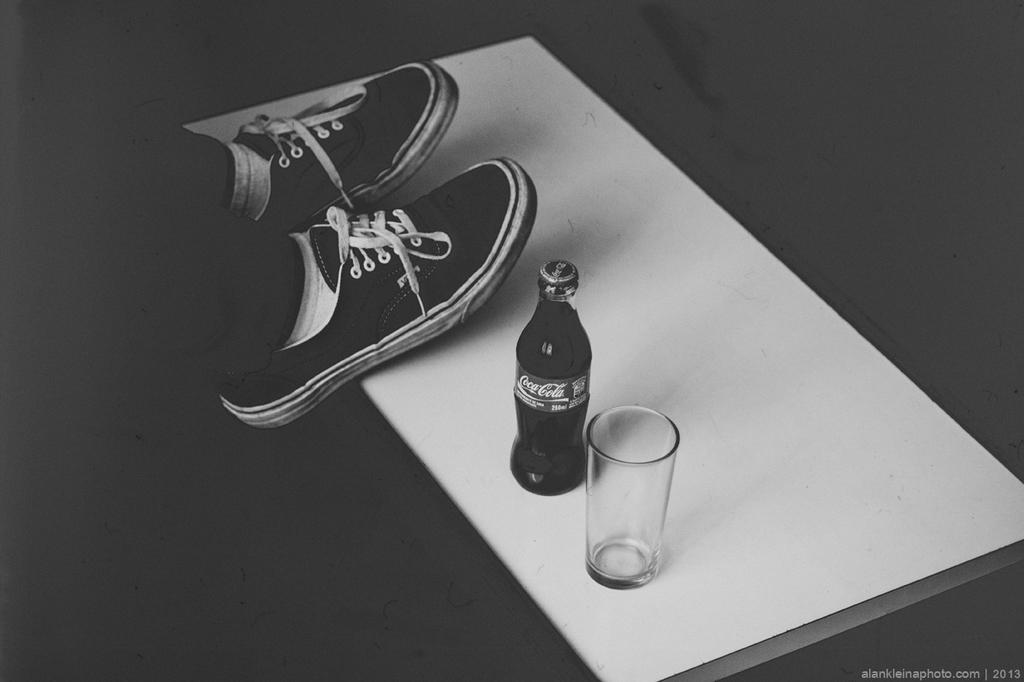What is visible in the image related to a person? There are a person's legs with shoes in the image. What beverage-related objects can be seen in the image? There is a bottle and a glass in the image. What is the background of the image? The objects are on a white sheet. Can you see the maid's face in the image? There is no maid present in the image, and therefore no face can be seen. 